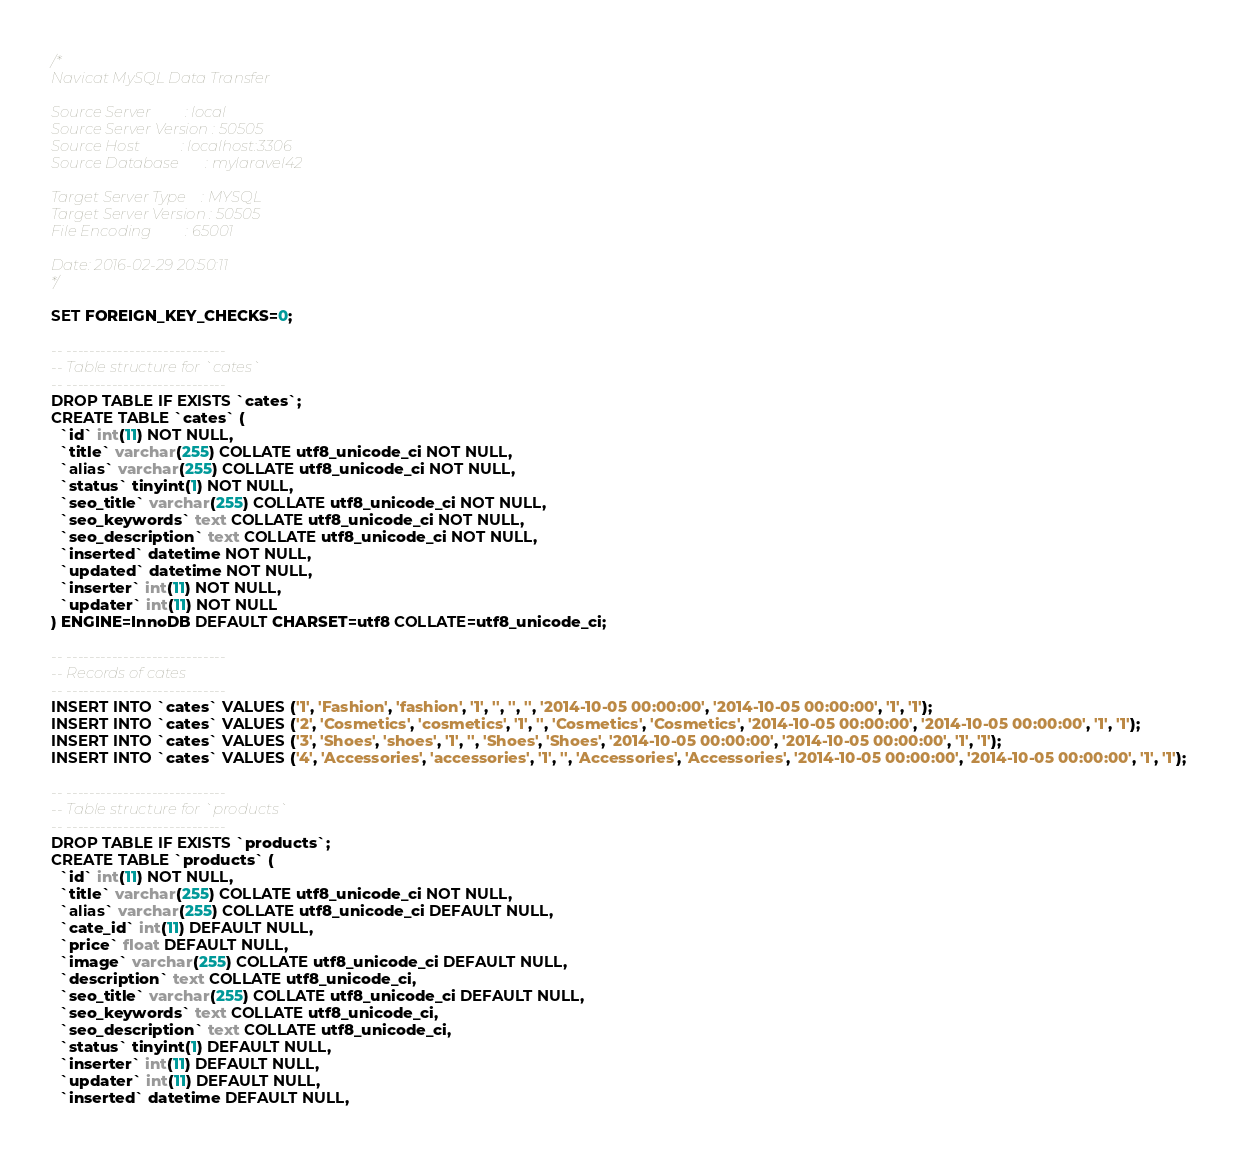Convert code to text. <code><loc_0><loc_0><loc_500><loc_500><_SQL_>/*
Navicat MySQL Data Transfer

Source Server         : local
Source Server Version : 50505
Source Host           : localhost:3306
Source Database       : mylaravel42

Target Server Type    : MYSQL
Target Server Version : 50505
File Encoding         : 65001

Date: 2016-02-29 20:50:11
*/

SET FOREIGN_KEY_CHECKS=0;

-- ----------------------------
-- Table structure for `cates`
-- ----------------------------
DROP TABLE IF EXISTS `cates`;
CREATE TABLE `cates` (
  `id` int(11) NOT NULL,
  `title` varchar(255) COLLATE utf8_unicode_ci NOT NULL,
  `alias` varchar(255) COLLATE utf8_unicode_ci NOT NULL,
  `status` tinyint(1) NOT NULL,
  `seo_title` varchar(255) COLLATE utf8_unicode_ci NOT NULL,
  `seo_keywords` text COLLATE utf8_unicode_ci NOT NULL,
  `seo_description` text COLLATE utf8_unicode_ci NOT NULL,
  `inserted` datetime NOT NULL,
  `updated` datetime NOT NULL,
  `inserter` int(11) NOT NULL,
  `updater` int(11) NOT NULL
) ENGINE=InnoDB DEFAULT CHARSET=utf8 COLLATE=utf8_unicode_ci;

-- ----------------------------
-- Records of cates
-- ----------------------------
INSERT INTO `cates` VALUES ('1', 'Fashion', 'fashion', '1', '', '', '', '2014-10-05 00:00:00', '2014-10-05 00:00:00', '1', '1');
INSERT INTO `cates` VALUES ('2', 'Cosmetics', 'cosmetics', '1', '', 'Cosmetics', 'Cosmetics', '2014-10-05 00:00:00', '2014-10-05 00:00:00', '1', '1');
INSERT INTO `cates` VALUES ('3', 'Shoes', 'shoes', '1', '', 'Shoes', 'Shoes', '2014-10-05 00:00:00', '2014-10-05 00:00:00', '1', '1');
INSERT INTO `cates` VALUES ('4', 'Accessories', 'accessories', '1', '', 'Accessories', 'Accessories', '2014-10-05 00:00:00', '2014-10-05 00:00:00', '1', '1');

-- ----------------------------
-- Table structure for `products`
-- ----------------------------
DROP TABLE IF EXISTS `products`;
CREATE TABLE `products` (
  `id` int(11) NOT NULL,
  `title` varchar(255) COLLATE utf8_unicode_ci NOT NULL,
  `alias` varchar(255) COLLATE utf8_unicode_ci DEFAULT NULL,
  `cate_id` int(11) DEFAULT NULL,
  `price` float DEFAULT NULL,
  `image` varchar(255) COLLATE utf8_unicode_ci DEFAULT NULL,
  `description` text COLLATE utf8_unicode_ci,
  `seo_title` varchar(255) COLLATE utf8_unicode_ci DEFAULT NULL,
  `seo_keywords` text COLLATE utf8_unicode_ci,
  `seo_description` text COLLATE utf8_unicode_ci,
  `status` tinyint(1) DEFAULT NULL,
  `inserter` int(11) DEFAULT NULL,
  `updater` int(11) DEFAULT NULL,
  `inserted` datetime DEFAULT NULL,</code> 